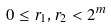Convert formula to latex. <formula><loc_0><loc_0><loc_500><loc_500>0 \leq r _ { 1 } , r _ { 2 } < 2 ^ { m }</formula> 